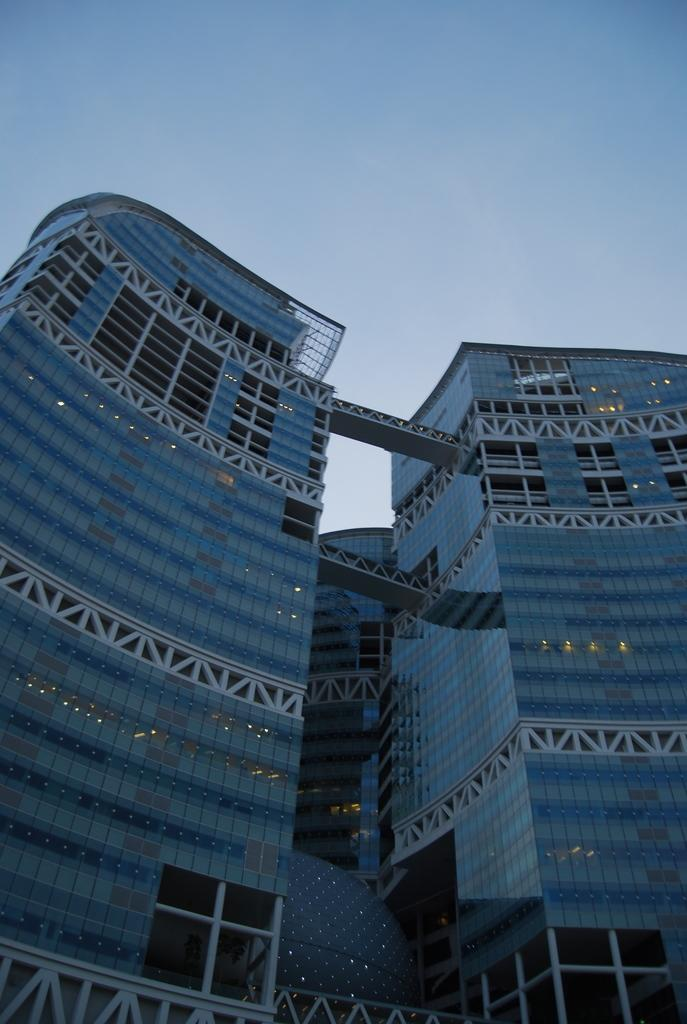What type of structure is present in the image? There is a building in the image. What feature can be seen on the building? The building has windows. What is visible at the top of the image? The sky is visible at the top of the image. What type of store can be seen advertising its products in the image? There is no store or advertisement present in the image; it only features a building with windows and the sky visible at the top. 